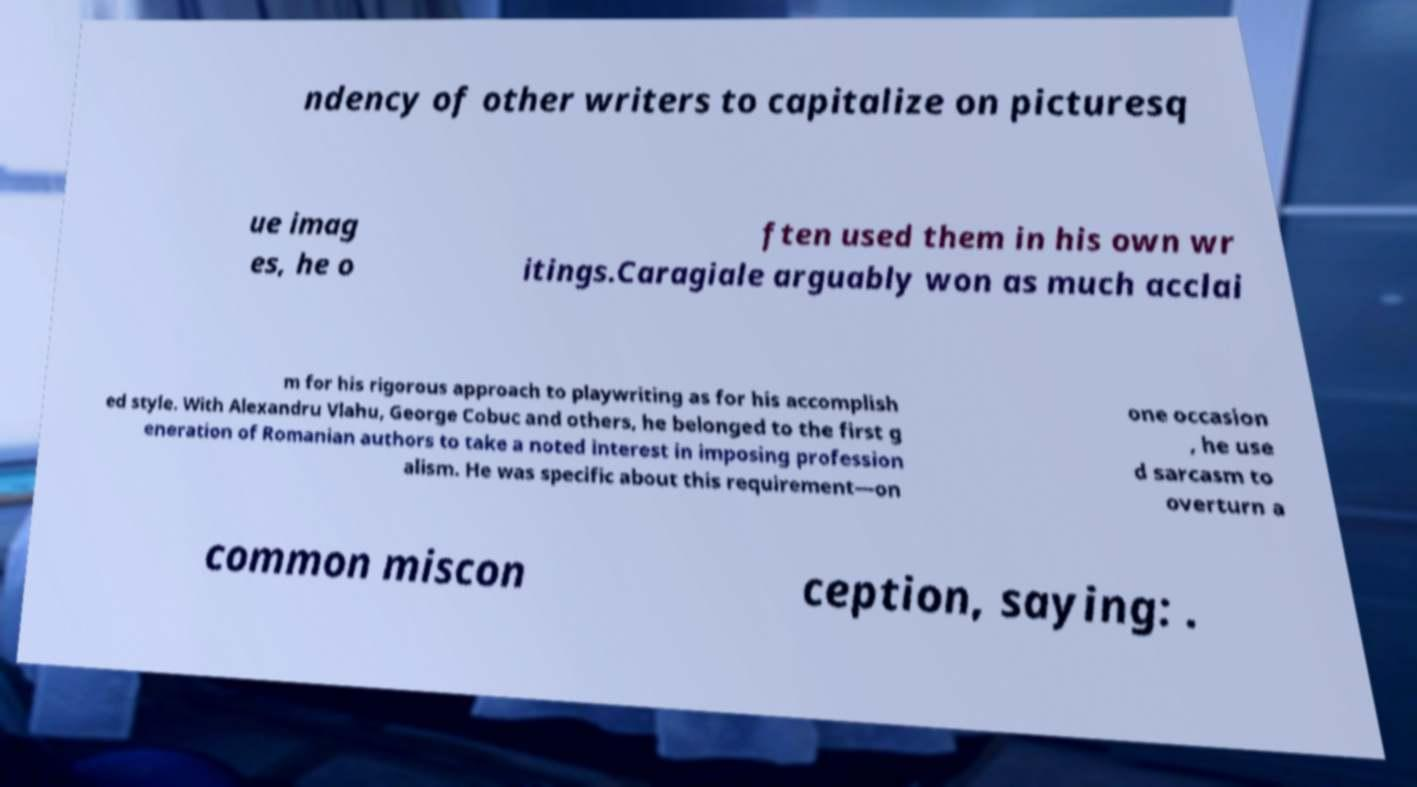What messages or text are displayed in this image? I need them in a readable, typed format. ndency of other writers to capitalize on picturesq ue imag es, he o ften used them in his own wr itings.Caragiale arguably won as much acclai m for his rigorous approach to playwriting as for his accomplish ed style. With Alexandru Vlahu, George Cobuc and others, he belonged to the first g eneration of Romanian authors to take a noted interest in imposing profession alism. He was specific about this requirement—on one occasion , he use d sarcasm to overturn a common miscon ception, saying: . 